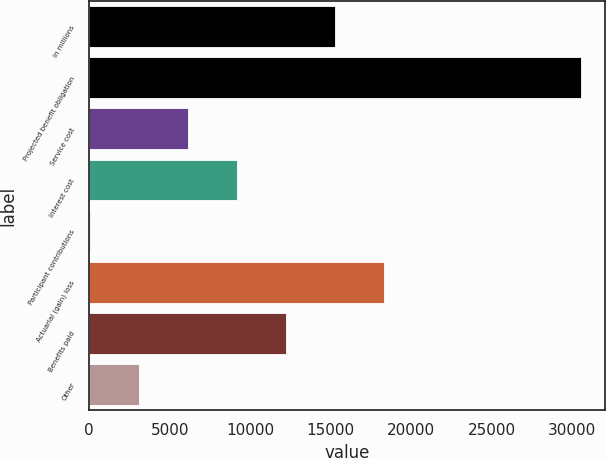Convert chart. <chart><loc_0><loc_0><loc_500><loc_500><bar_chart><fcel>in millions<fcel>Projected benefit obligation<fcel>Service cost<fcel>Interest cost<fcel>Participant contributions<fcel>Actuarial (gain) loss<fcel>Benefits paid<fcel>Other<nl><fcel>15272<fcel>30525<fcel>6120.2<fcel>9170.8<fcel>19<fcel>18322.6<fcel>12221.4<fcel>3069.6<nl></chart> 